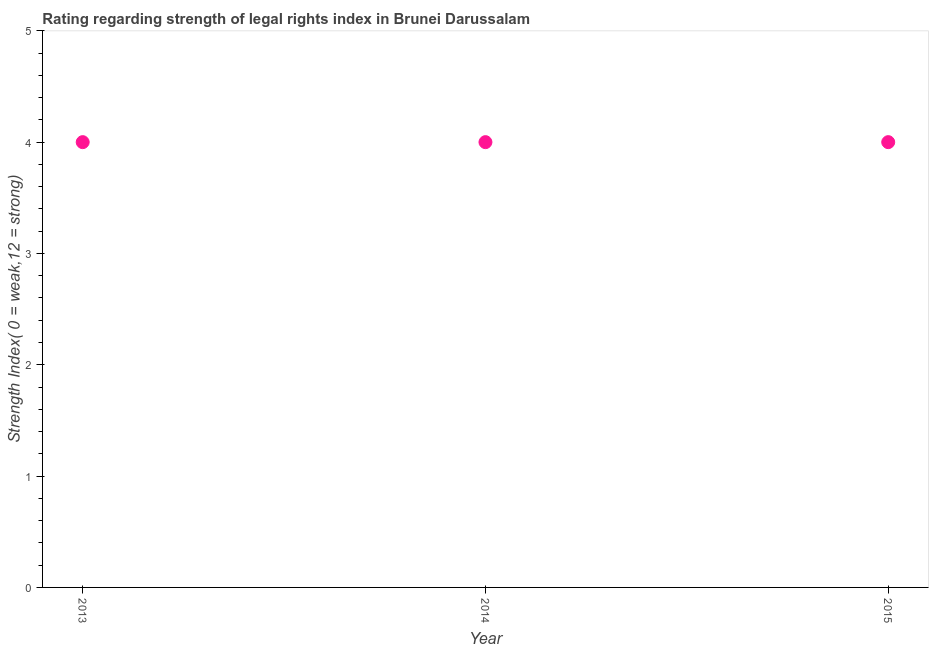What is the strength of legal rights index in 2013?
Ensure brevity in your answer.  4. Across all years, what is the maximum strength of legal rights index?
Provide a succinct answer. 4. Across all years, what is the minimum strength of legal rights index?
Your answer should be compact. 4. What is the sum of the strength of legal rights index?
Offer a very short reply. 12. What is the ratio of the strength of legal rights index in 2013 to that in 2015?
Provide a short and direct response. 1. Is the strength of legal rights index in 2013 less than that in 2015?
Make the answer very short. No. What is the difference between the highest and the lowest strength of legal rights index?
Offer a very short reply. 0. Does the strength of legal rights index monotonically increase over the years?
Provide a short and direct response. No. How many dotlines are there?
Make the answer very short. 1. How many years are there in the graph?
Make the answer very short. 3. What is the difference between two consecutive major ticks on the Y-axis?
Make the answer very short. 1. Does the graph contain grids?
Your answer should be very brief. No. What is the title of the graph?
Offer a terse response. Rating regarding strength of legal rights index in Brunei Darussalam. What is the label or title of the X-axis?
Ensure brevity in your answer.  Year. What is the label or title of the Y-axis?
Make the answer very short. Strength Index( 0 = weak,12 = strong). What is the difference between the Strength Index( 0 = weak,12 = strong) in 2014 and 2015?
Your response must be concise. 0. What is the ratio of the Strength Index( 0 = weak,12 = strong) in 2013 to that in 2014?
Offer a very short reply. 1. 